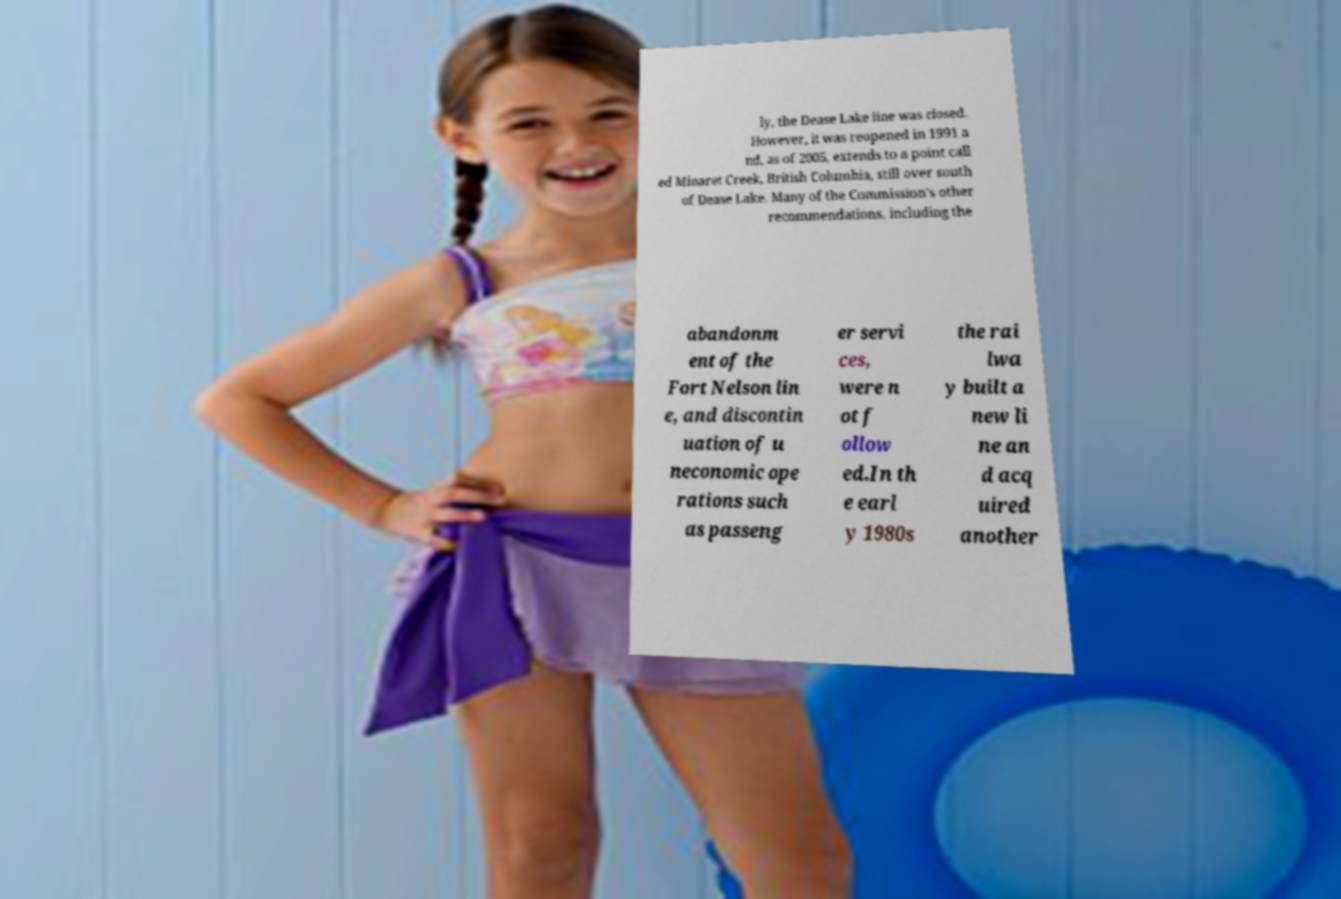There's text embedded in this image that I need extracted. Can you transcribe it verbatim? ly, the Dease Lake line was closed. However, it was reopened in 1991 a nd, as of 2005, extends to a point call ed Minaret Creek, British Columbia, still over south of Dease Lake. Many of the Commission's other recommendations, including the abandonm ent of the Fort Nelson lin e, and discontin uation of u neconomic ope rations such as passeng er servi ces, were n ot f ollow ed.In th e earl y 1980s the rai lwa y built a new li ne an d acq uired another 